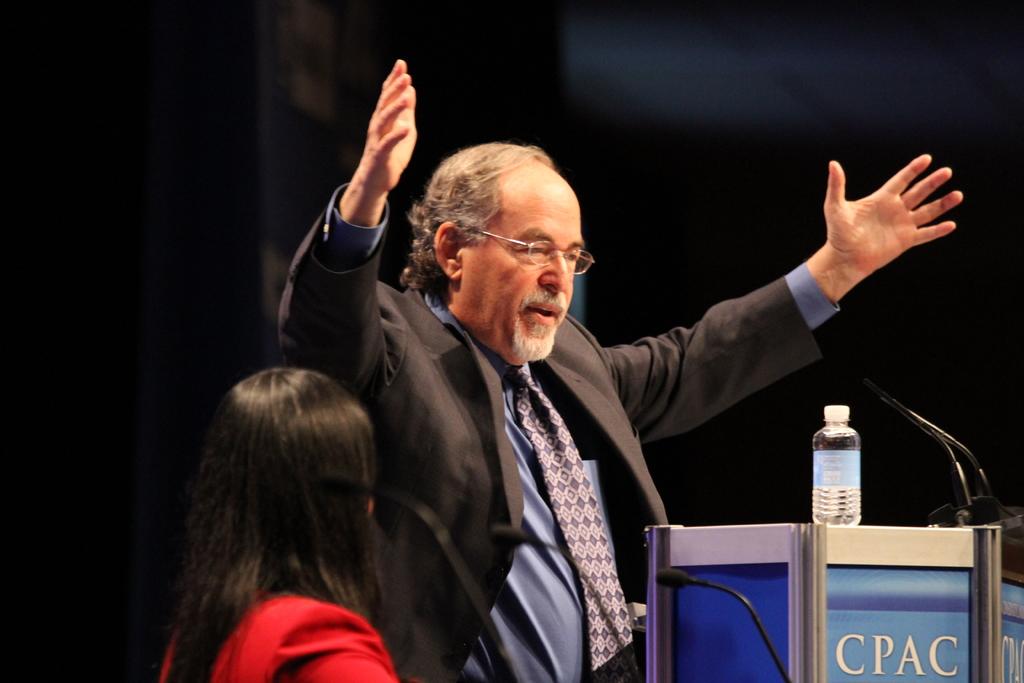Where is the man speaking?
Provide a short and direct response. Cpac. 